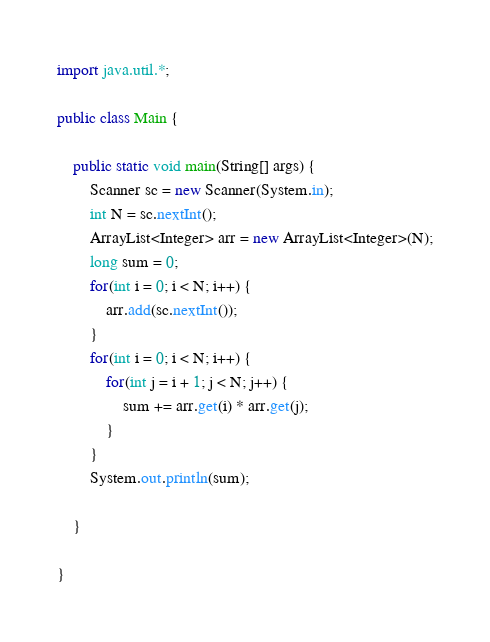<code> <loc_0><loc_0><loc_500><loc_500><_Java_>import java.util.*;

public class Main {

	public static void main(String[] args) {
		Scanner sc = new Scanner(System.in);
		int N = sc.nextInt();
		ArrayList<Integer> arr = new ArrayList<Integer>(N);
		long sum = 0;
		for(int i = 0; i < N; i++) {
			arr.add(sc.nextInt());
		}
		for(int i = 0; i < N; i++) {
			for(int j = i + 1; j < N; j++) {
				sum += arr.get(i) * arr.get(j);				
			}
		}
		System.out.println(sum);

	}

}
</code> 